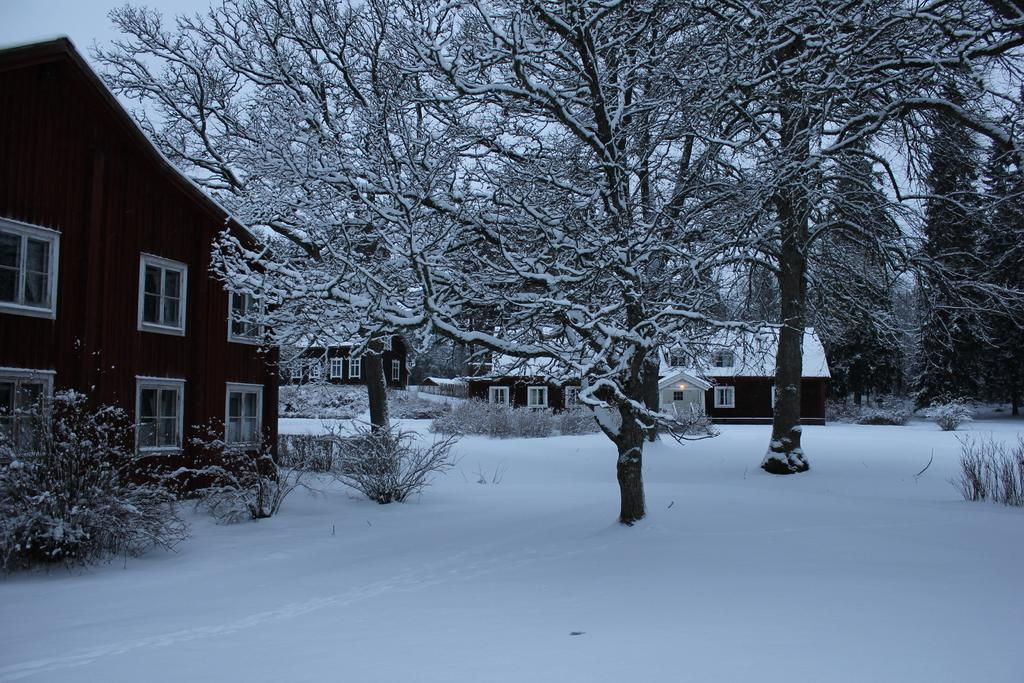What type of structures can be seen in the image? There are houses in the image. How are the trees in the image affected by the weather? The trees in the image are fully covered with snow. What type of utensil is used to stir the eggnog in the image? There is no eggnog or spoon present in the image. Is there a rifle visible in the image? There is no rifle present in the image. 